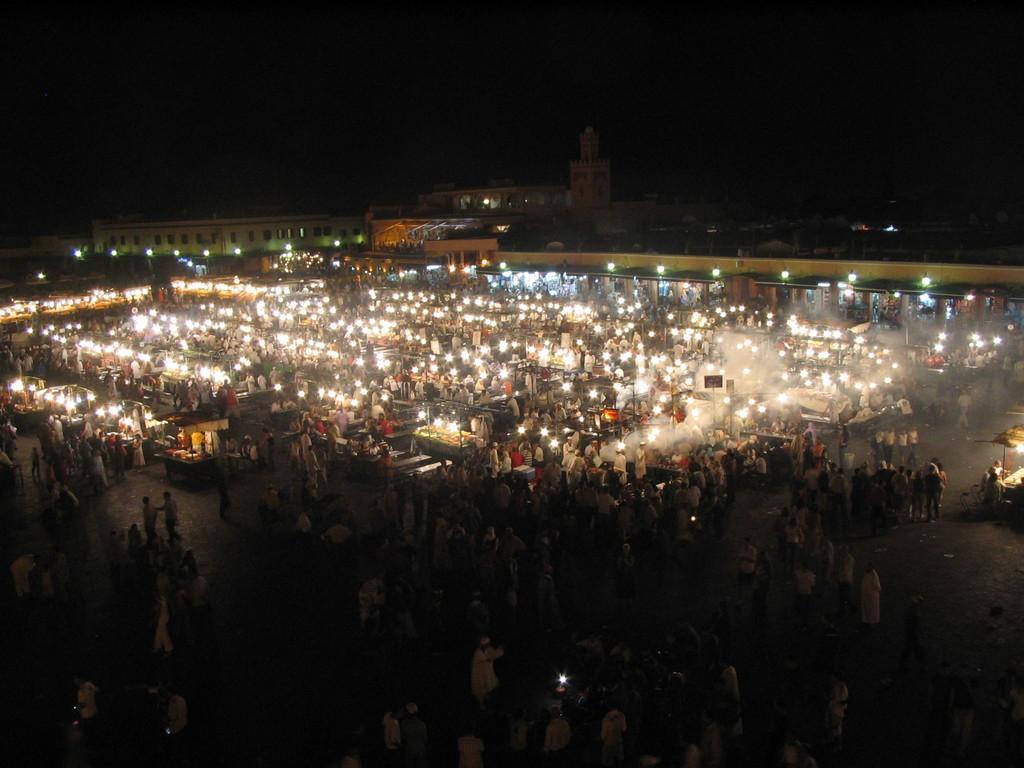How would you summarize this image in a sentence or two? It looks like a market, there are many people that are walking on the road and these are the lights. In the long back side there are buildings. 